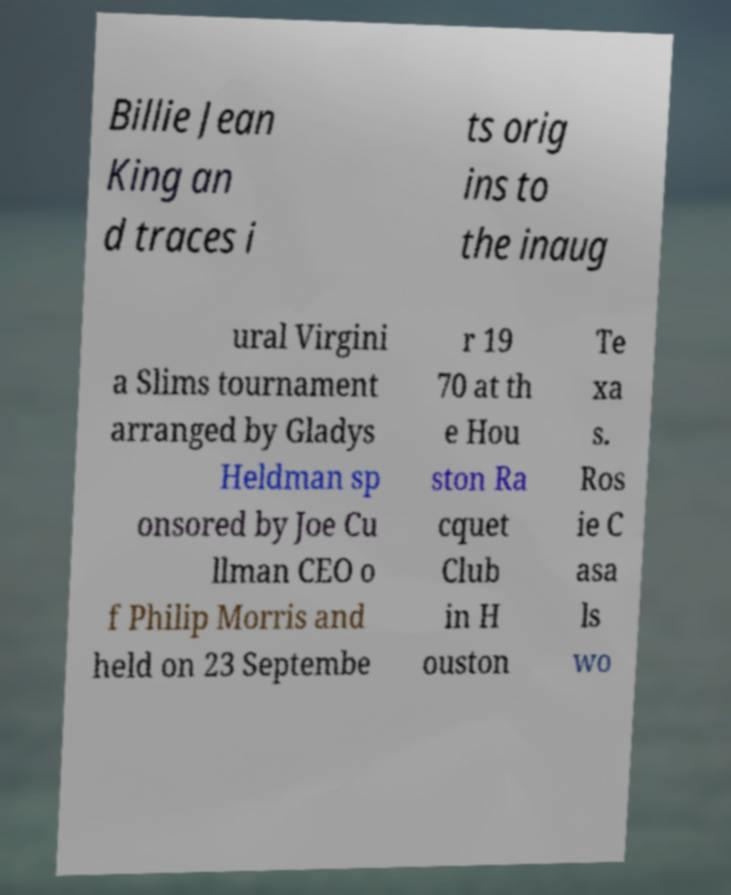I need the written content from this picture converted into text. Can you do that? Billie Jean King an d traces i ts orig ins to the inaug ural Virgini a Slims tournament arranged by Gladys Heldman sp onsored by Joe Cu llman CEO o f Philip Morris and held on 23 Septembe r 19 70 at th e Hou ston Ra cquet Club in H ouston Te xa s. Ros ie C asa ls wo 